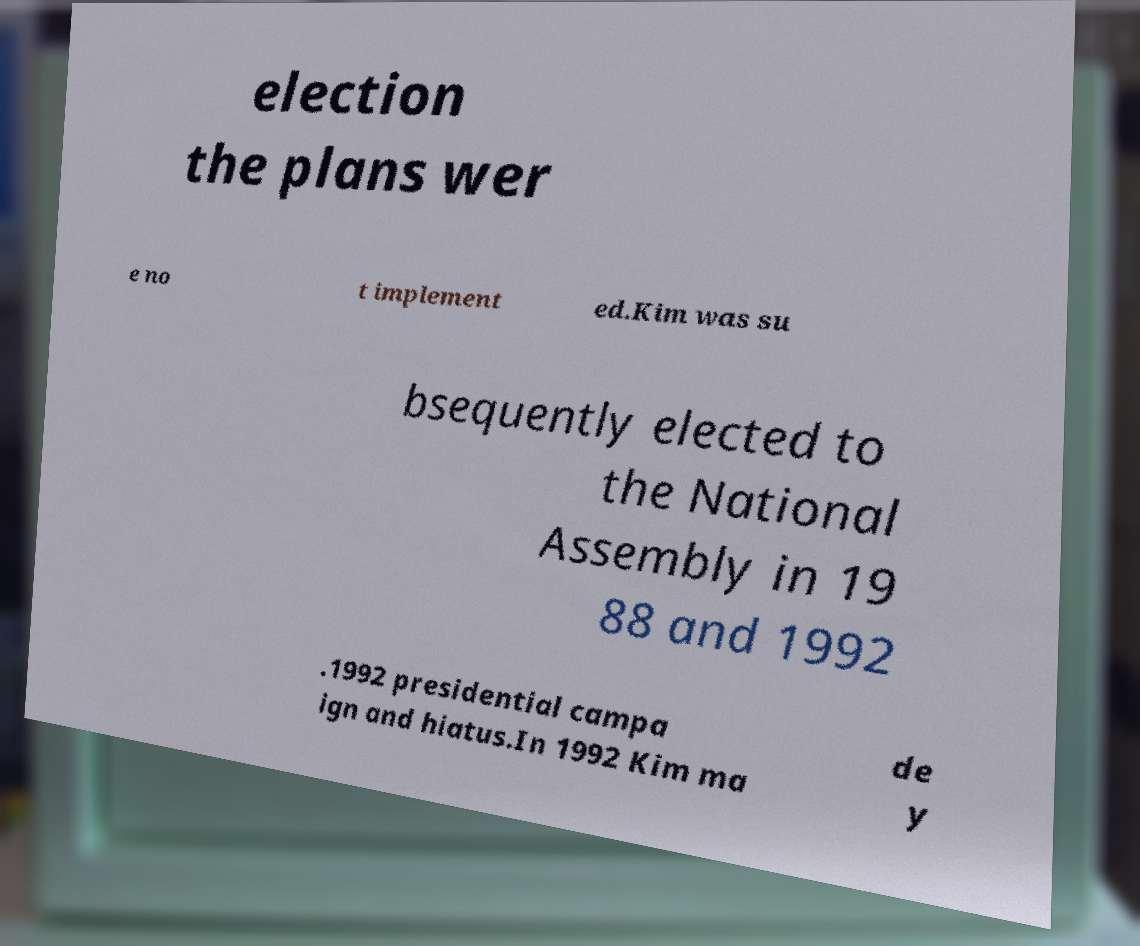Could you extract and type out the text from this image? election the plans wer e no t implement ed.Kim was su bsequently elected to the National Assembly in 19 88 and 1992 .1992 presidential campa ign and hiatus.In 1992 Kim ma de y 